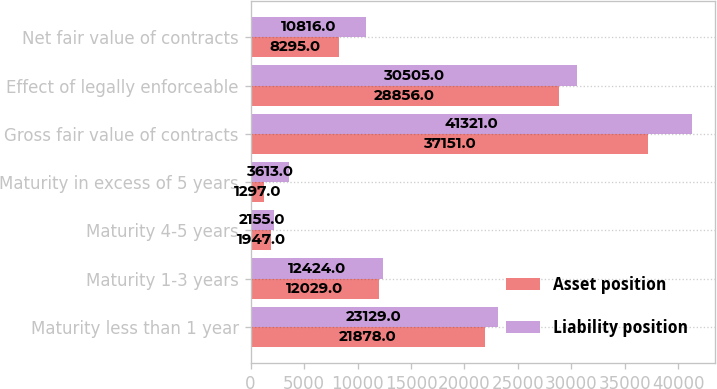Convert chart to OTSL. <chart><loc_0><loc_0><loc_500><loc_500><stacked_bar_chart><ecel><fcel>Maturity less than 1 year<fcel>Maturity 1-3 years<fcel>Maturity 4-5 years<fcel>Maturity in excess of 5 years<fcel>Gross fair value of contracts<fcel>Effect of legally enforceable<fcel>Net fair value of contracts<nl><fcel>Asset position<fcel>21878<fcel>12029<fcel>1947<fcel>1297<fcel>37151<fcel>28856<fcel>8295<nl><fcel>Liability position<fcel>23129<fcel>12424<fcel>2155<fcel>3613<fcel>41321<fcel>30505<fcel>10816<nl></chart> 